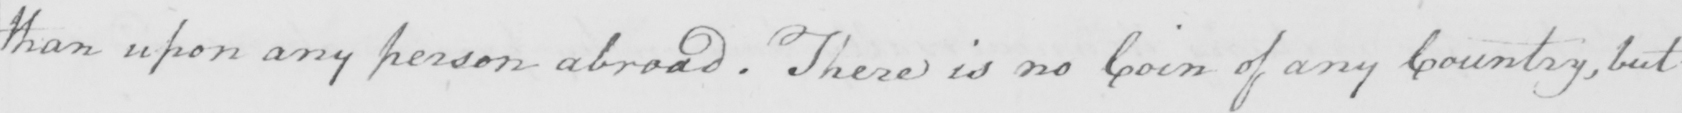What does this handwritten line say? than upon any person abroad  . There is no Coin of any Country , but 